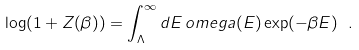Convert formula to latex. <formula><loc_0><loc_0><loc_500><loc_500>\log ( 1 + Z ( \beta ) ) = \int _ { \Lambda } ^ { \infty } d E \, o m e g a ( E ) \exp ( - \beta E ) \ .</formula> 